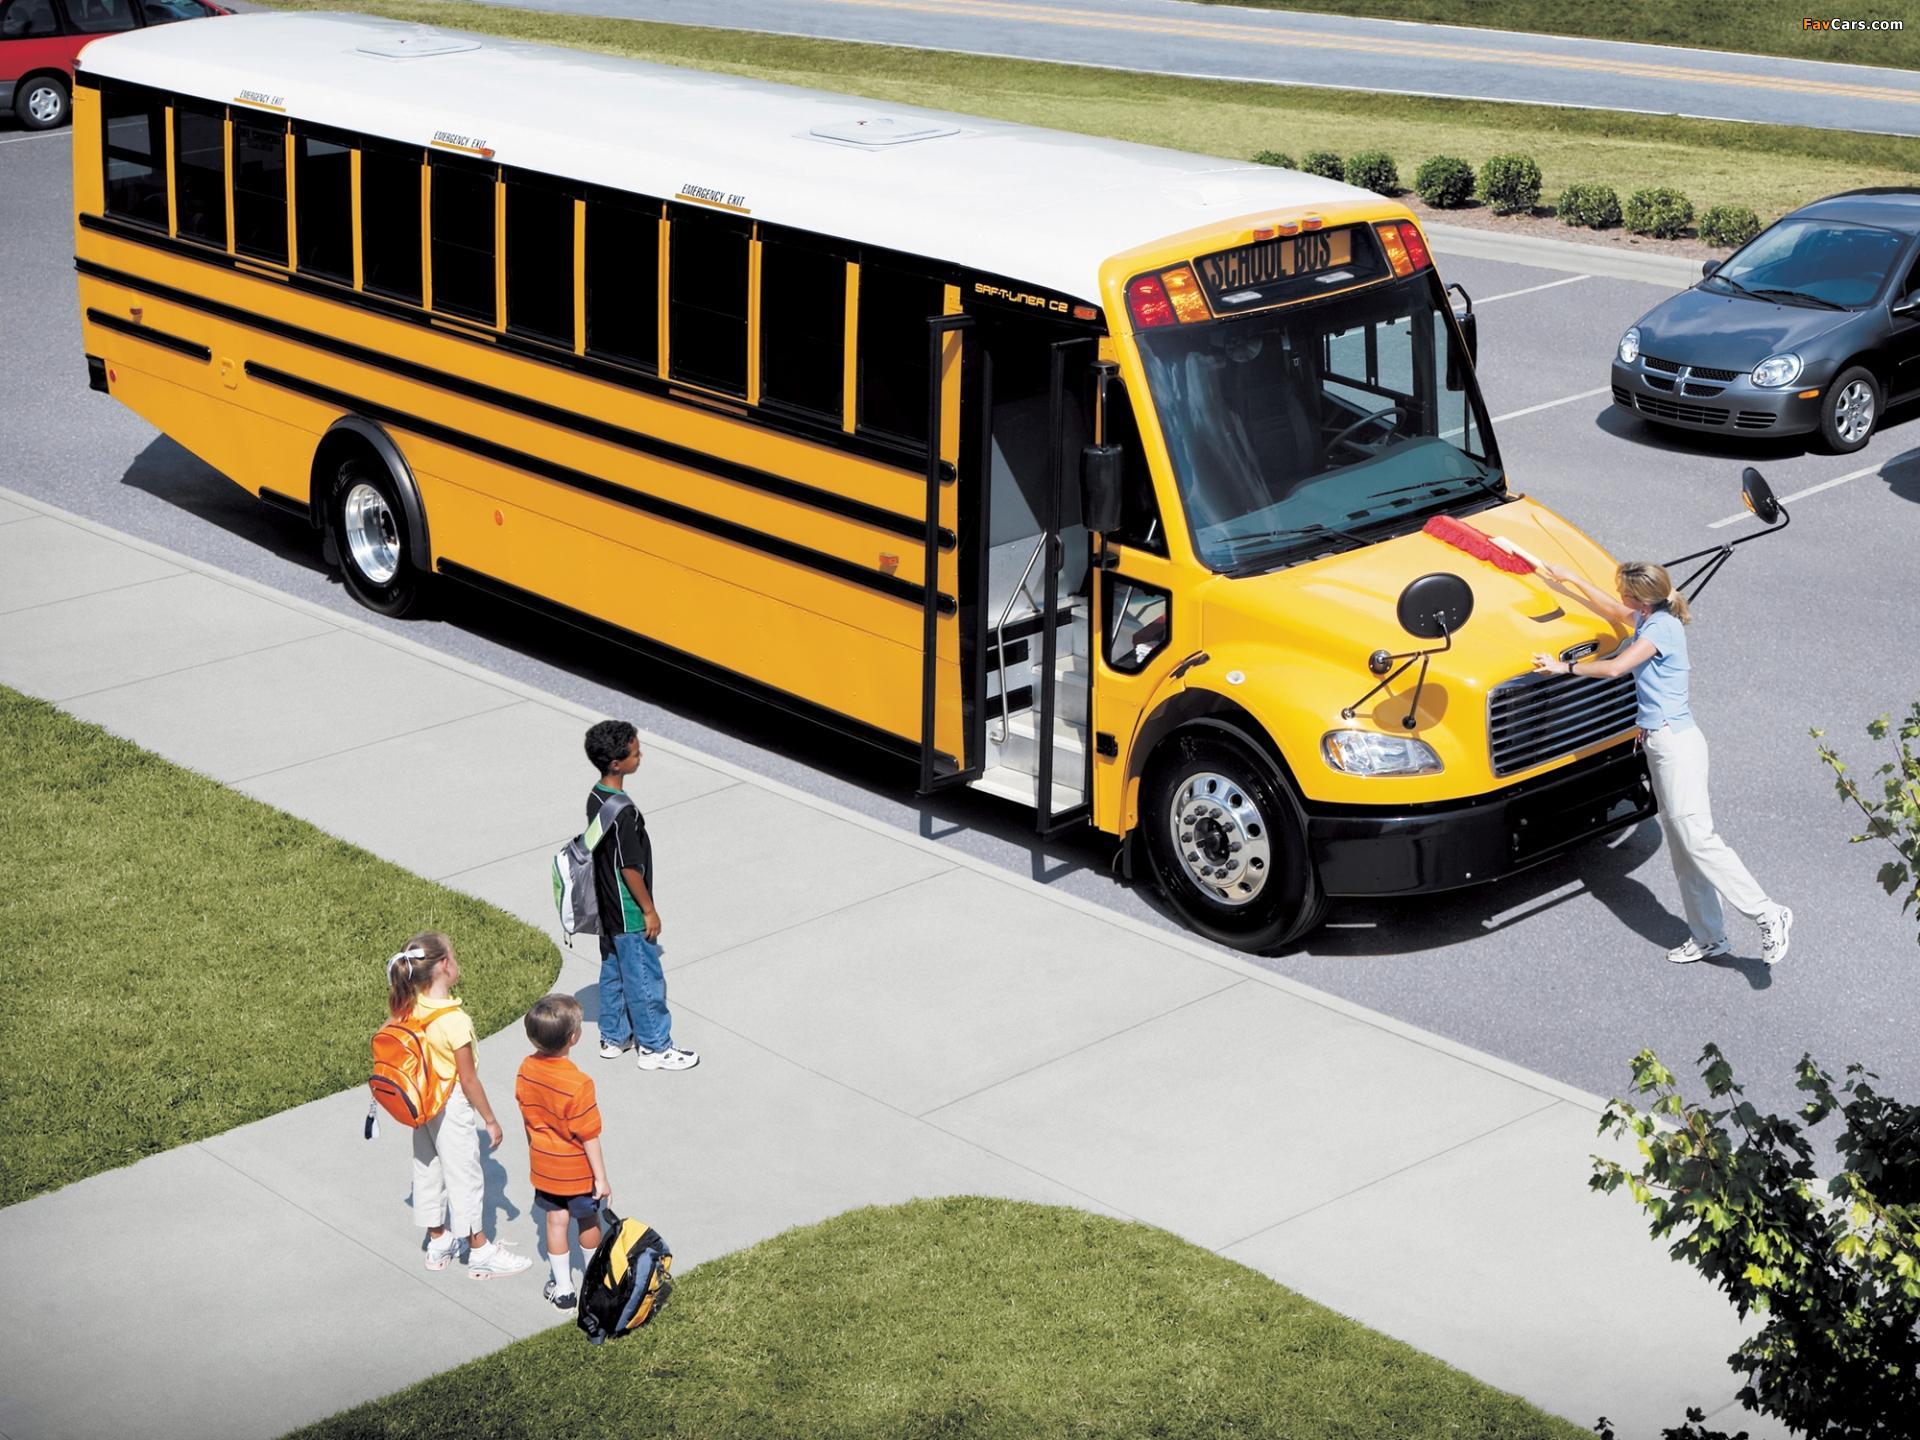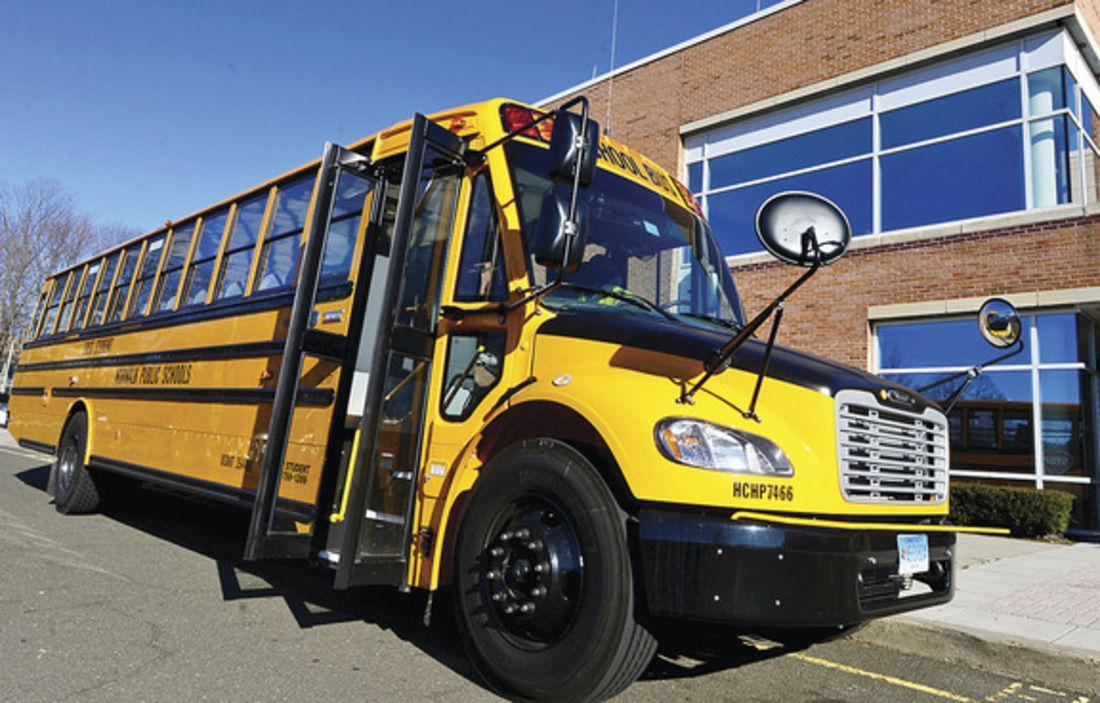The first image is the image on the left, the second image is the image on the right. For the images shown, is this caption "Each image shows a flat-fronted bus with a black-and-yellow striped line on its black bumper, and the buses on the left and right face the same direction." true? Answer yes or no. No. 